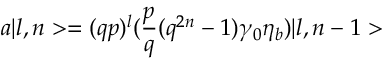Convert formula to latex. <formula><loc_0><loc_0><loc_500><loc_500>a | l , n > = ( q p ) ^ { l } ( { \frac { p } { q } } ( q ^ { 2 n } - 1 ) \gamma _ { 0 } \eta _ { b } ) | l , n - 1 ></formula> 